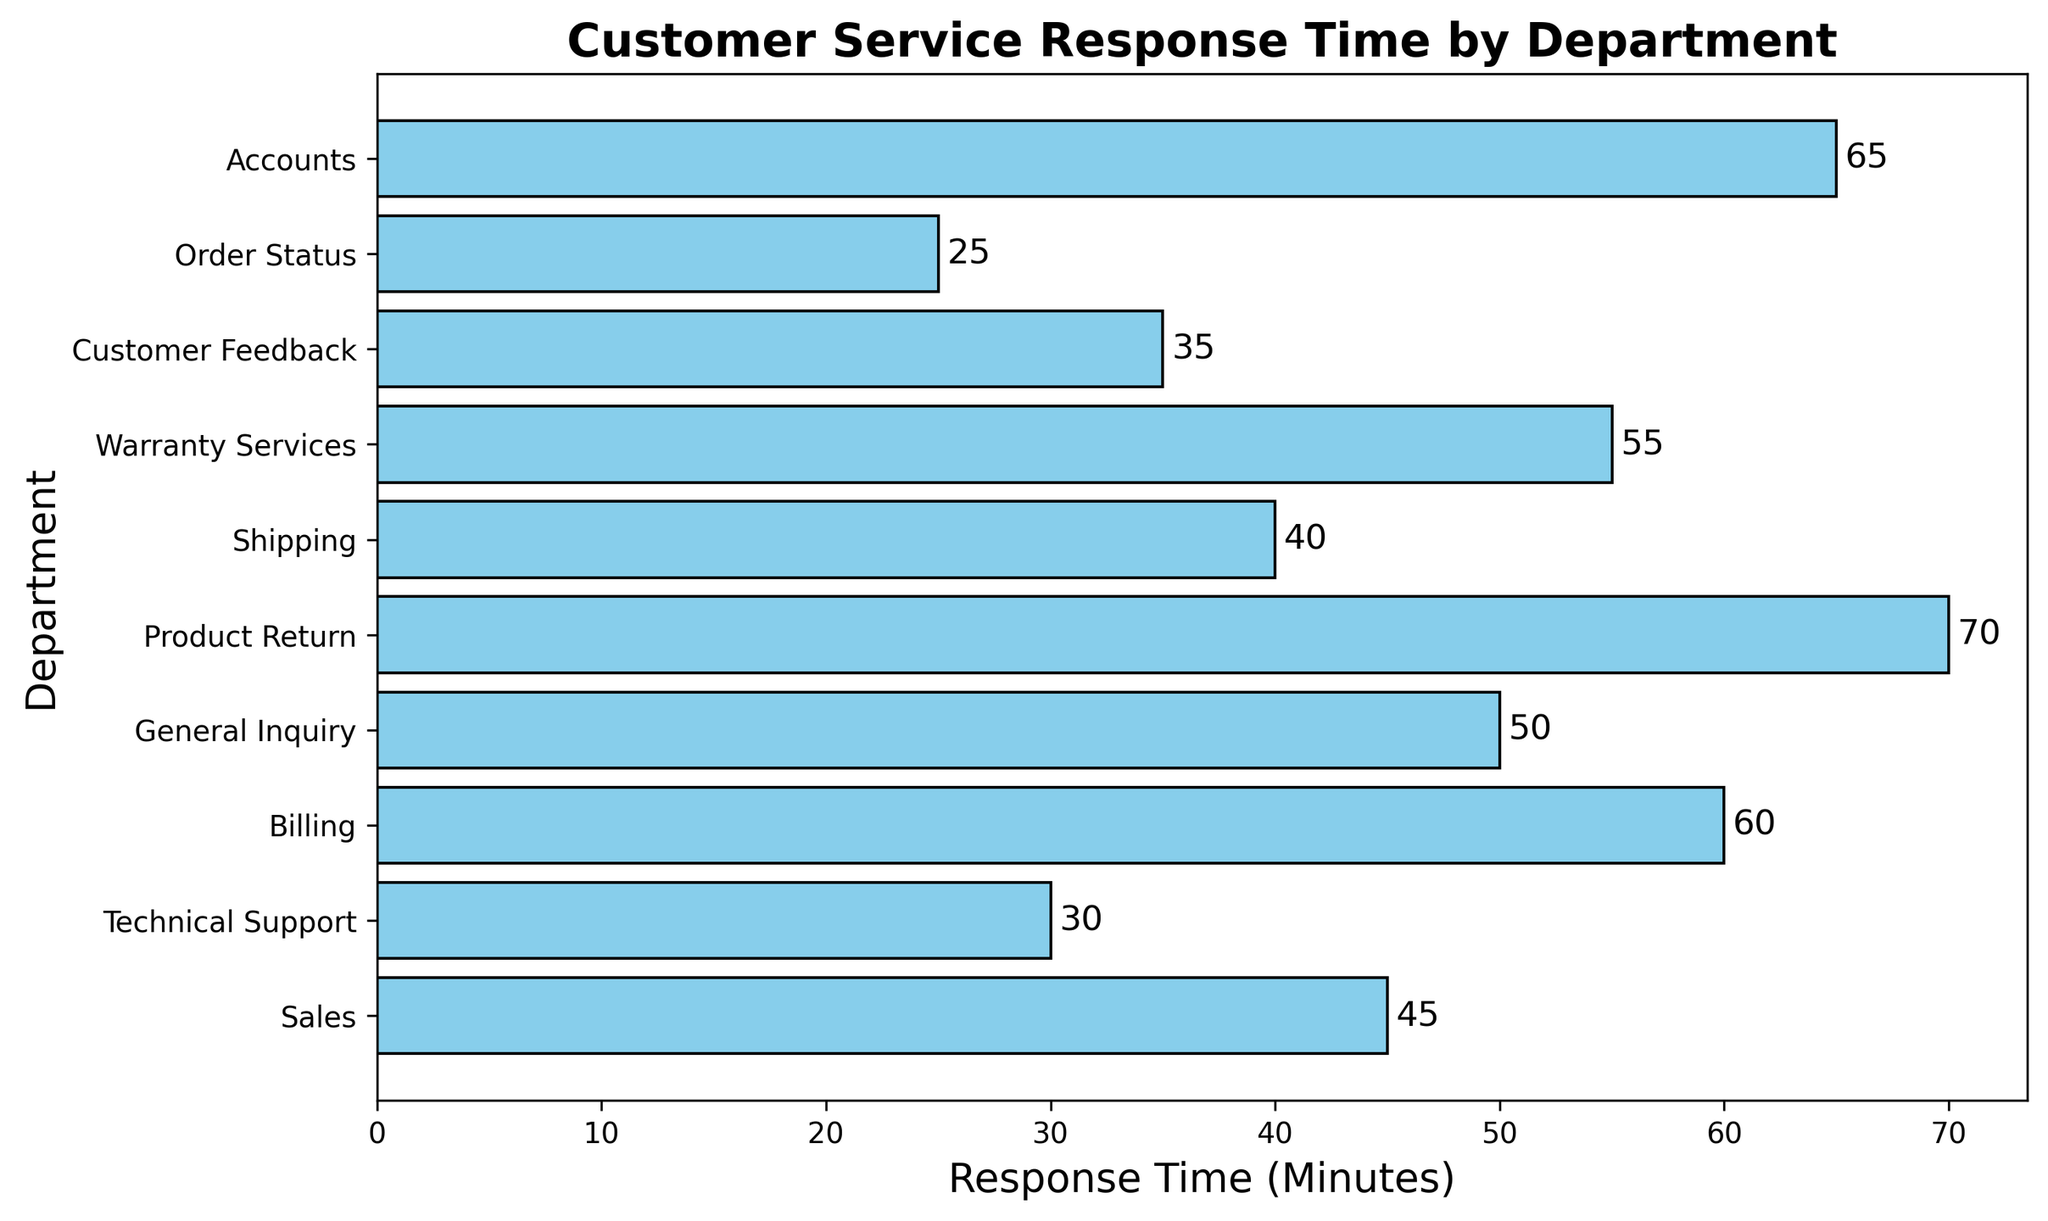What is the general inquiry department's response time? The chart shows the response time for each department, and we can see that the bar for the General Inquiry department is labeled with a response time of 50 minutes.
Answer: 50 minutes Which department has the quickest response time? By examining the lengths of the bars, we can see that the Order Status department has the shortest bar, indicating the quickest response time of 25 minutes.
Answer: Order Status How much longer is the response time for the Billing department compared to Technical Support? The response time for Billing is 60 minutes and for Technical Support is 30 minutes. The difference is calculated as 60 - 30.
Answer: 30 minutes What is the average response time across all departments? To find the average, sum up all the response times and divide by the number of departments. The total is 45 + 30 + 60 + 50 + 70 + 40 + 55 + 35 + 25 + 65 = 475. The number of departments is 10. Therefore, the average response time is 475 / 10.
Answer: 47.5 minutes Which department takes the longest to respond? The department with the longest response time has the longest bar. The Product Return department has the longest bar with a response time of 70 minutes.
Answer: Product Return What is the combined response time for the Sales, Billing, and Shipping departments? The response times for Sales, Billing, and Shipping are 45, 60, and 40 minutes respectively. The combined response time is 45 + 60 + 40.
Answer: 145 minutes How does the Technical Support response time compare to the Customer Feedback department? The response time for Technical Support is 30 minutes, and for Customer Feedback, it is 35 minutes. Since 30 is less than 35, Technical Support responds quicker.
Answer: Technical Support is quicker What is the difference in response times between the Warranty Services and Accounts departments? The response times for Warranty Services and Accounts are 55 minutes and 65 minutes respectively. The difference is 65 - 55.
Answer: 10 minutes How many departments have a response time shorter than 50 minutes? From the bars, the departments with response times shorter than 50 minutes are Technical Support (30), Shipping (40), Customer Feedback (35), and Order Status (25). There are 4 such departments.
Answer: 4 departments If both the highest and lowest response times are removed, what is the new average response time? First, remove the highest (Product Return, 70 minutes) and the lowest (Order Status, 25 minutes) response times. The remaining response times are: 45, 30, 60, 50, 40, 55, 35, 65. Sum these values (45 + 30 + 60 + 50 + 40 + 55 + 35 + 65 = 380) and divide by the new number of data points (8). The new average is 380 / 8.
Answer: 47.5 minutes 